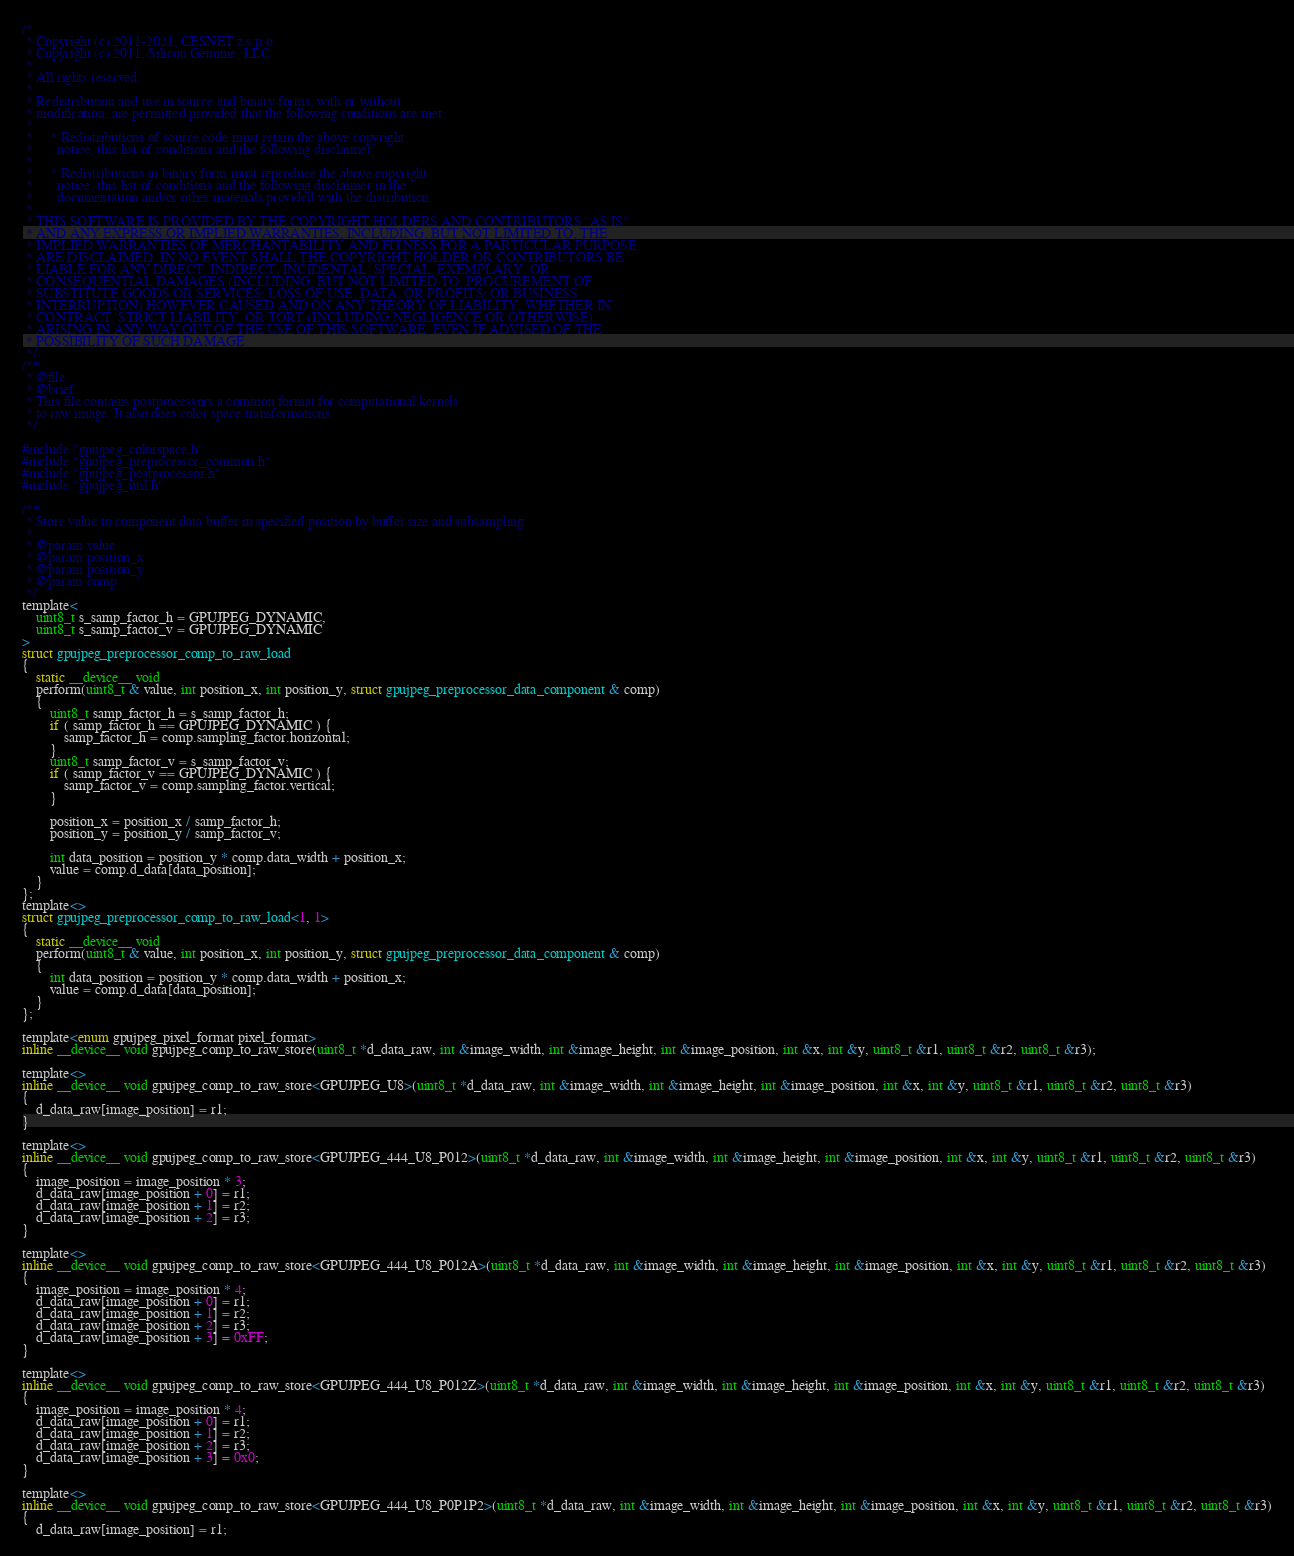<code> <loc_0><loc_0><loc_500><loc_500><_Cuda_>/*
 * Copyright (c) 2011-2021, CESNET z.s.p.o
 * Copyright (c) 2011, Silicon Genome, LLC.
 *
 * All rights reserved.
 *
 * Redistribution and use in source and binary forms, with or without
 * modification, are permitted provided that the following conditions are met:
 *
 *     * Redistributions of source code must retain the above copyright
 *       notice, this list of conditions and the following disclaimer.
 *
 *     * Redistributions in binary form must reproduce the above copyright
 *       notice, this list of conditions and the following disclaimer in the
 *       documentation and/or other materials provided with the distribution.
 *
 * THIS SOFTWARE IS PROVIDED BY THE COPYRIGHT HOLDERS AND CONTRIBUTORS "AS IS"
 * AND ANY EXPRESS OR IMPLIED WARRANTIES, INCLUDING, BUT NOT LIMITED TO, THE
 * IMPLIED WARRANTIES OF MERCHANTABILITY AND FITNESS FOR A PARTICULAR PURPOSE
 * ARE DISCLAIMED. IN NO EVENT SHALL THE COPYRIGHT HOLDER OR CONTRIBUTORS BE
 * LIABLE FOR ANY DIRECT, INDIRECT, INCIDENTAL, SPECIAL, EXEMPLARY, OR
 * CONSEQUENTIAL DAMAGES (INCLUDING, BUT NOT LIMITED TO, PROCUREMENT OF
 * SUBSTITUTE GOODS OR SERVICES; LOSS OF USE, DATA, OR PROFITS; OR BUSINESS
 * INTERRUPTION) HOWEVER CAUSED AND ON ANY THEORY OF LIABILITY, WHETHER IN
 * CONTRACT, STRICT LIABILITY, OR TORT (INCLUDING NEGLIGENCE OR OTHERWISE)
 * ARISING IN ANY WAY OUT OF THE USE OF THIS SOFTWARE, EVEN IF ADVISED OF THE
 * POSSIBILITY OF SUCH DAMAGE.
 */
/**
 * @file
 * @brief
 * This file contains postprocessors a common format for computational kernels
 * to raw image. It also does color space transformations.
 */

#include "gpujpeg_colorspace.h"
#include "gpujpeg_preprocessor_common.h"
#include "gpujpeg_postprocessor.h"
#include "gpujpeg_util.h"

/**
 * Store value to component data buffer in specified position by buffer size and subsampling
 *
 * @param value
 * @param position_x
 * @param position_y
 * @param comp
 */
template<
    uint8_t s_samp_factor_h = GPUJPEG_DYNAMIC,
    uint8_t s_samp_factor_v = GPUJPEG_DYNAMIC
>
struct gpujpeg_preprocessor_comp_to_raw_load
{
    static __device__ void
    perform(uint8_t & value, int position_x, int position_y, struct gpujpeg_preprocessor_data_component & comp)
    {
        uint8_t samp_factor_h = s_samp_factor_h;
        if ( samp_factor_h == GPUJPEG_DYNAMIC ) {
            samp_factor_h = comp.sampling_factor.horizontal;
        }
        uint8_t samp_factor_v = s_samp_factor_v;
        if ( samp_factor_v == GPUJPEG_DYNAMIC ) {
            samp_factor_v = comp.sampling_factor.vertical;
        }

        position_x = position_x / samp_factor_h;
        position_y = position_y / samp_factor_v;

        int data_position = position_y * comp.data_width + position_x;
        value = comp.d_data[data_position];
    }
};
template<>
struct gpujpeg_preprocessor_comp_to_raw_load<1, 1>
{
    static __device__ void
    perform(uint8_t & value, int position_x, int position_y, struct gpujpeg_preprocessor_data_component & comp)
    {
        int data_position = position_y * comp.data_width + position_x;
        value = comp.d_data[data_position];
    }
};

template<enum gpujpeg_pixel_format pixel_format>
inline __device__ void gpujpeg_comp_to_raw_store(uint8_t *d_data_raw, int &image_width, int &image_height, int &image_position, int &x, int &y, uint8_t &r1, uint8_t &r2, uint8_t &r3);

template<>
inline __device__ void gpujpeg_comp_to_raw_store<GPUJPEG_U8>(uint8_t *d_data_raw, int &image_width, int &image_height, int &image_position, int &x, int &y, uint8_t &r1, uint8_t &r2, uint8_t &r3)
{
    d_data_raw[image_position] = r1;
}

template<>
inline __device__ void gpujpeg_comp_to_raw_store<GPUJPEG_444_U8_P012>(uint8_t *d_data_raw, int &image_width, int &image_height, int &image_position, int &x, int &y, uint8_t &r1, uint8_t &r2, uint8_t &r3)
{
    image_position = image_position * 3;
    d_data_raw[image_position + 0] = r1;
    d_data_raw[image_position + 1] = r2;
    d_data_raw[image_position + 2] = r3;
}

template<>
inline __device__ void gpujpeg_comp_to_raw_store<GPUJPEG_444_U8_P012A>(uint8_t *d_data_raw, int &image_width, int &image_height, int &image_position, int &x, int &y, uint8_t &r1, uint8_t &r2, uint8_t &r3)
{
    image_position = image_position * 4;
    d_data_raw[image_position + 0] = r1;
    d_data_raw[image_position + 1] = r2;
    d_data_raw[image_position + 2] = r3;
    d_data_raw[image_position + 3] = 0xFF;
}

template<>
inline __device__ void gpujpeg_comp_to_raw_store<GPUJPEG_444_U8_P012Z>(uint8_t *d_data_raw, int &image_width, int &image_height, int &image_position, int &x, int &y, uint8_t &r1, uint8_t &r2, uint8_t &r3)
{
    image_position = image_position * 4;
    d_data_raw[image_position + 0] = r1;
    d_data_raw[image_position + 1] = r2;
    d_data_raw[image_position + 2] = r3;
    d_data_raw[image_position + 3] = 0x0;
}

template<>
inline __device__ void gpujpeg_comp_to_raw_store<GPUJPEG_444_U8_P0P1P2>(uint8_t *d_data_raw, int &image_width, int &image_height, int &image_position, int &x, int &y, uint8_t &r1, uint8_t &r2, uint8_t &r3)
{
    d_data_raw[image_position] = r1;</code> 